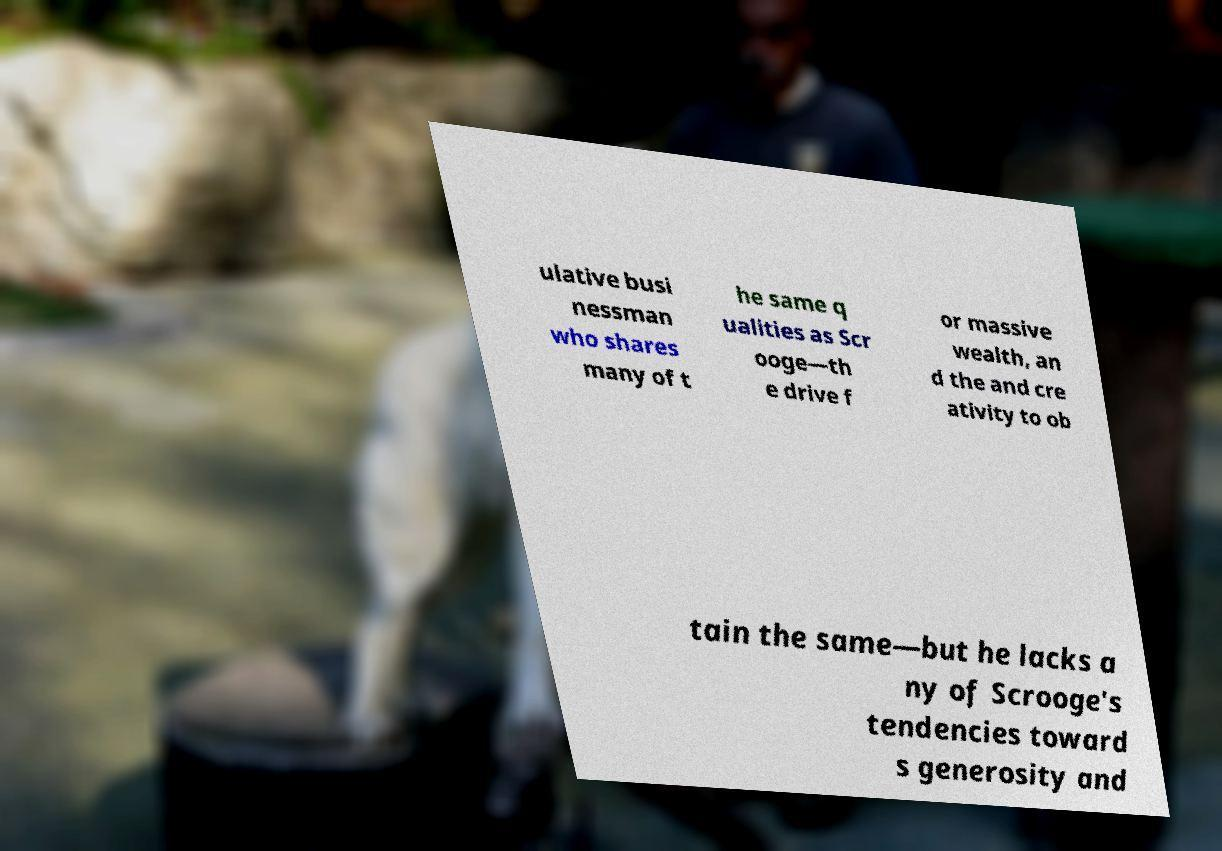For documentation purposes, I need the text within this image transcribed. Could you provide that? ulative busi nessman who shares many of t he same q ualities as Scr ooge—th e drive f or massive wealth, an d the and cre ativity to ob tain the same—but he lacks a ny of Scrooge's tendencies toward s generosity and 